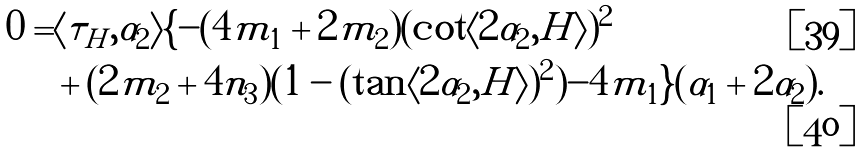Convert formula to latex. <formula><loc_0><loc_0><loc_500><loc_500>0 = & \langle \tau _ { H } , \alpha _ { 2 } \rangle \{ - ( 4 m _ { 1 } + 2 m _ { 2 } ) ( \cot \langle 2 \alpha _ { 2 } , H \rangle ) ^ { 2 } \\ & + ( 2 m _ { 2 } + 4 n _ { 3 } ) ( 1 - ( \tan \langle 2 \alpha _ { 2 } , H \rangle ) ^ { 2 } ) - 4 m _ { 1 } \} ( \alpha _ { 1 } + 2 \alpha _ { 2 } ) .</formula> 